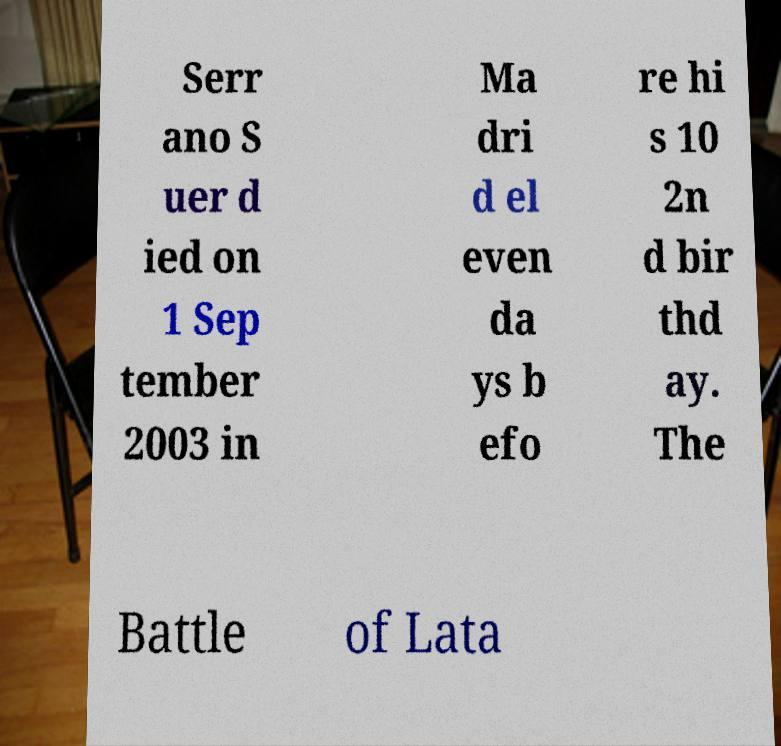Could you extract and type out the text from this image? Serr ano S uer d ied on 1 Sep tember 2003 in Ma dri d el even da ys b efo re hi s 10 2n d bir thd ay. The Battle of Lata 